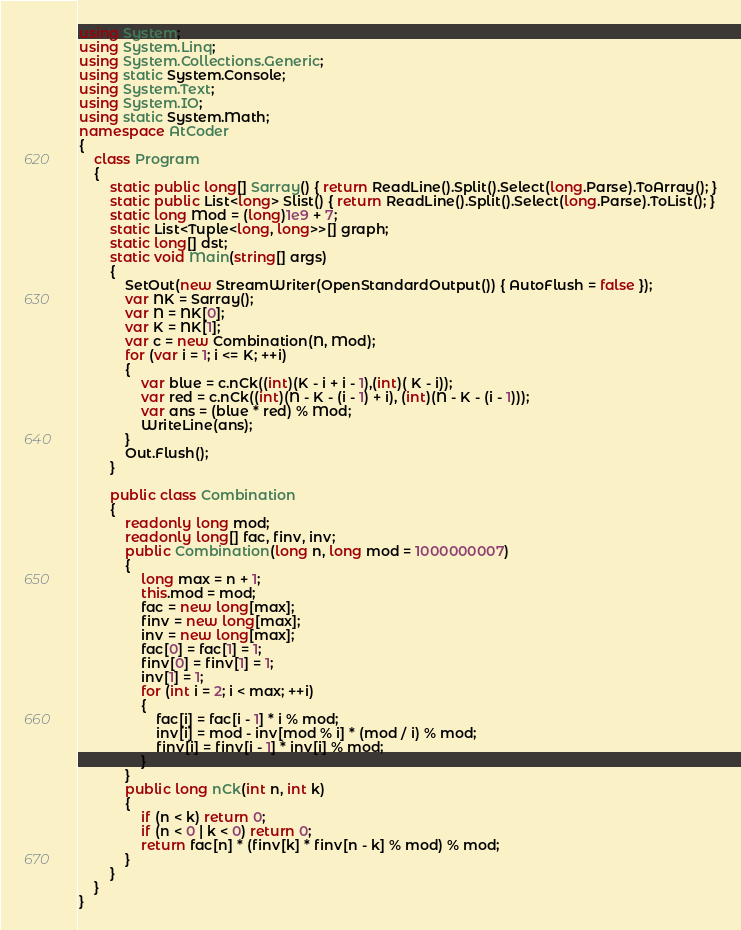<code> <loc_0><loc_0><loc_500><loc_500><_C#_>using System;
using System.Linq;
using System.Collections.Generic;
using static System.Console;
using System.Text;
using System.IO;
using static System.Math;
namespace AtCoder
{
    class Program
    {
        static public long[] Sarray() { return ReadLine().Split().Select(long.Parse).ToArray(); }
        static public List<long> Slist() { return ReadLine().Split().Select(long.Parse).ToList(); }
        static long Mod = (long)1e9 + 7;
        static List<Tuple<long, long>>[] graph;
        static long[] dst;
        static void Main(string[] args)
        {
            SetOut(new StreamWriter(OpenStandardOutput()) { AutoFlush = false });
            var NK = Sarray();
            var N = NK[0];
            var K = NK[1];
            var c = new Combination(N, Mod);
            for (var i = 1; i <= K; ++i)
            {
                var blue = c.nCk((int)(K - i + i - 1),(int)( K - i));
                var red = c.nCk((int)(N - K - (i - 1) + i), (int)(N - K - (i - 1)));
                var ans = (blue * red) % Mod;
                WriteLine(ans);
            }
            Out.Flush();
        }

        public class Combination
        {
            readonly long mod;
            readonly long[] fac, finv, inv;
            public Combination(long n, long mod = 1000000007)
            {
                long max = n + 1;
                this.mod = mod;
                fac = new long[max];
                finv = new long[max];
                inv = new long[max];
                fac[0] = fac[1] = 1;
                finv[0] = finv[1] = 1;
                inv[1] = 1;
                for (int i = 2; i < max; ++i)
                {
                    fac[i] = fac[i - 1] * i % mod;
                    inv[i] = mod - inv[mod % i] * (mod / i) % mod;
                    finv[i] = finv[i - 1] * inv[i] % mod;
                }
            }
            public long nCk(int n, int k)
            {
                if (n < k) return 0;
                if (n < 0 | k < 0) return 0;
                return fac[n] * (finv[k] * finv[n - k] % mod) % mod;
            }
        }
    }
}</code> 